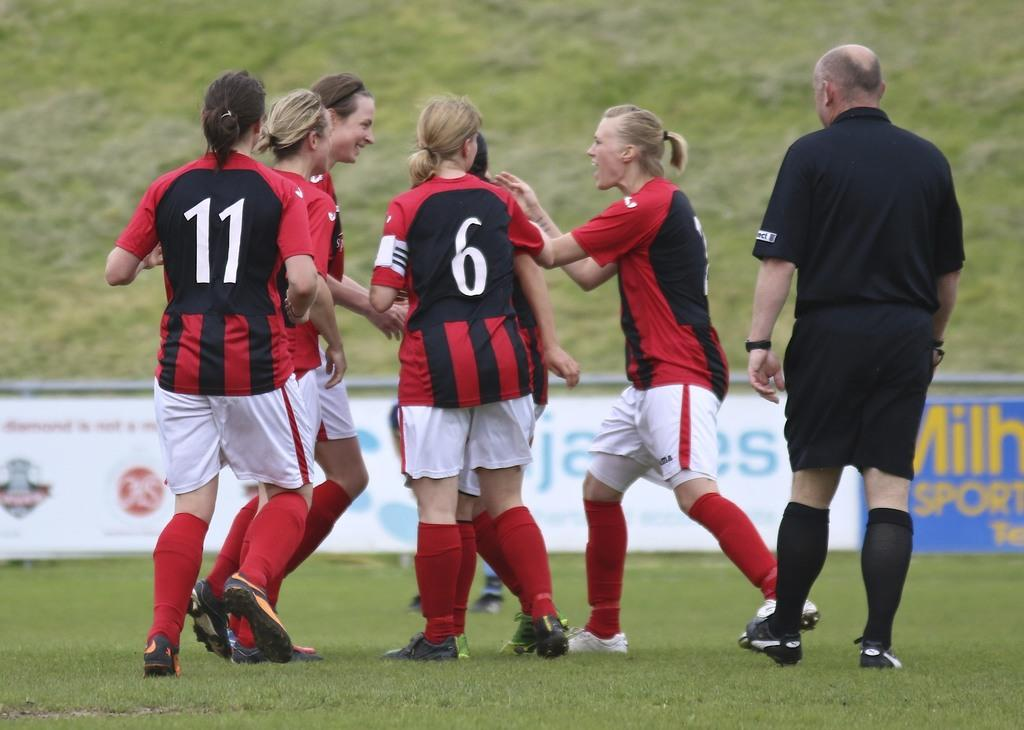What are the people in the image doing? The people in the image are standing on the ground. What can be seen hanging or displayed in the image? There is a banner with images and text in the image. What type of harmony is being played by the players in the image? There is no indication of any musical instruments or harmony in the image; the players are simply standing on the ground. 